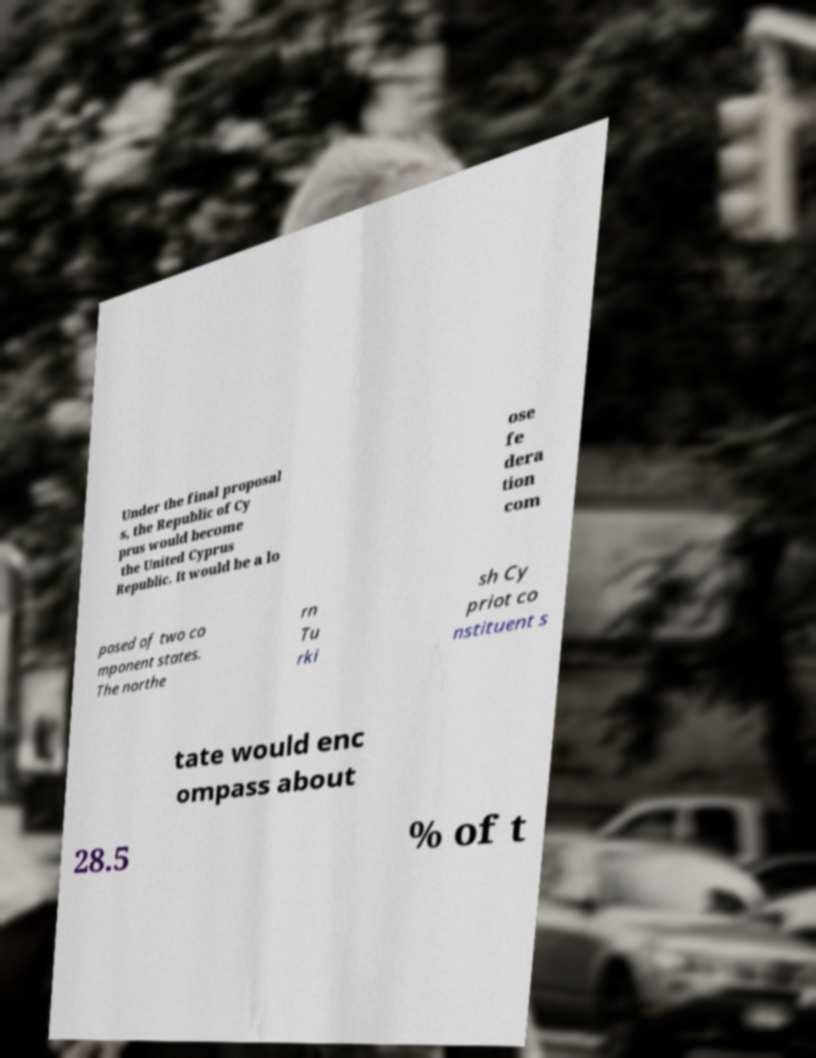I need the written content from this picture converted into text. Can you do that? Under the final proposal s, the Republic of Cy prus would become the United Cyprus Republic. It would be a lo ose fe dera tion com posed of two co mponent states. The northe rn Tu rki sh Cy priot co nstituent s tate would enc ompass about 28.5 % of t 